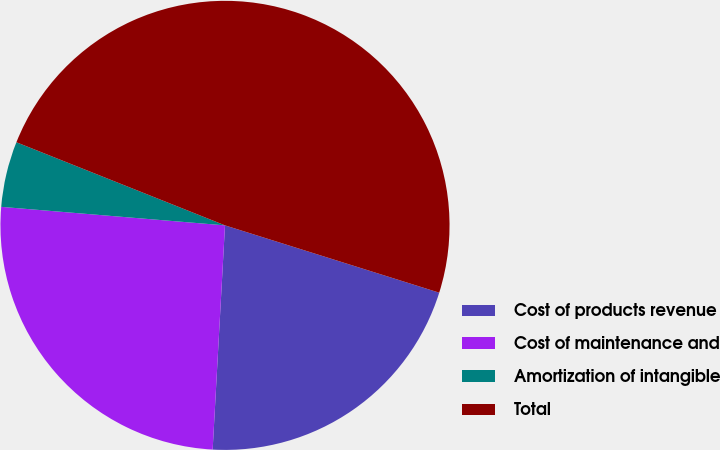Convert chart to OTSL. <chart><loc_0><loc_0><loc_500><loc_500><pie_chart><fcel>Cost of products revenue<fcel>Cost of maintenance and<fcel>Amortization of intangible<fcel>Total<nl><fcel>21.03%<fcel>25.44%<fcel>4.72%<fcel>48.81%<nl></chart> 